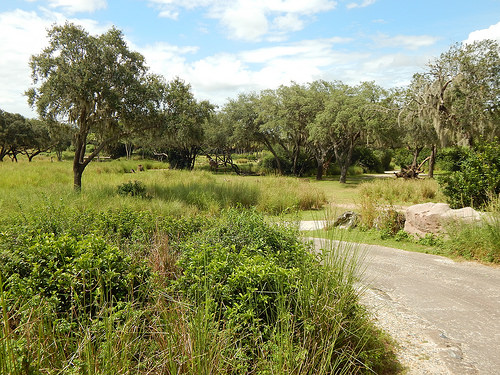<image>
Can you confirm if the tree is next to the sky? No. The tree is not positioned next to the sky. They are located in different areas of the scene. 